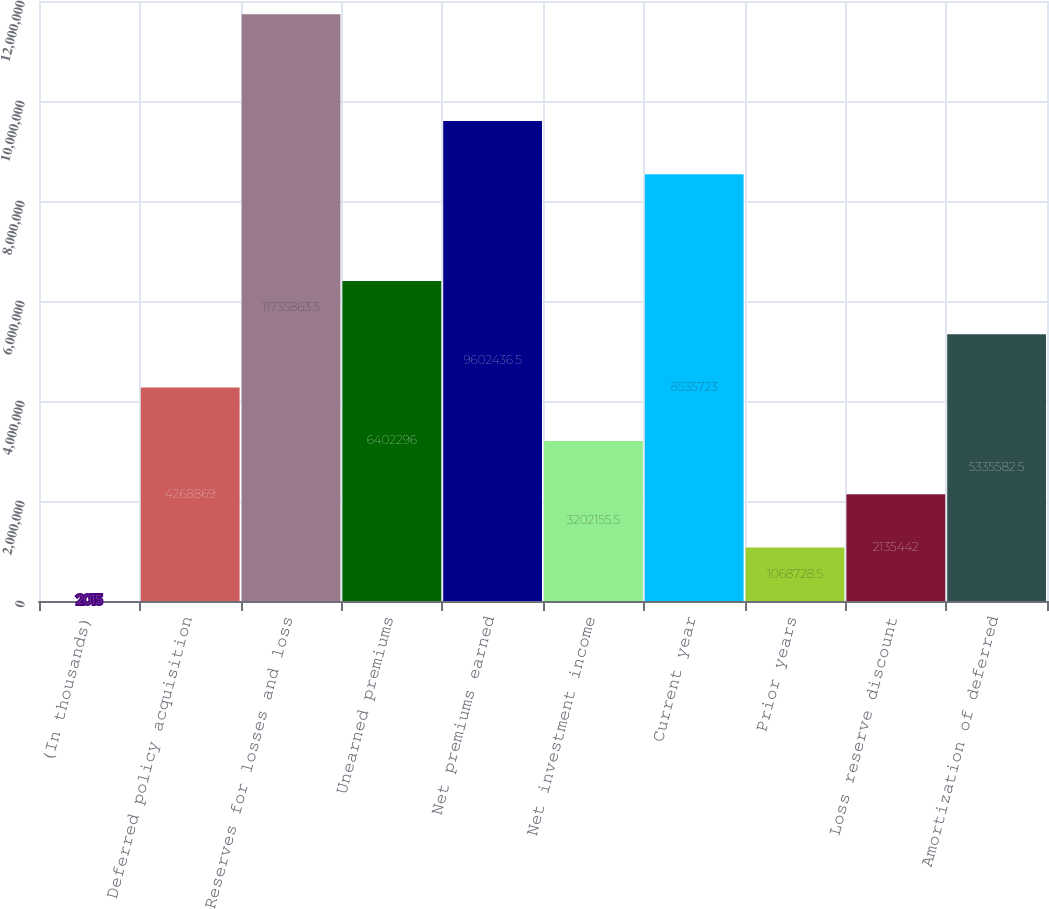Convert chart to OTSL. <chart><loc_0><loc_0><loc_500><loc_500><bar_chart><fcel>(In thousands)<fcel>Deferred policy acquisition<fcel>Reserves for losses and loss<fcel>Unearned premiums<fcel>Net premiums earned<fcel>Net investment income<fcel>Current year<fcel>Prior years<fcel>Loss reserve discount<fcel>Amortization of deferred<nl><fcel>2015<fcel>4.26887e+06<fcel>1.17359e+07<fcel>6.4023e+06<fcel>9.60244e+06<fcel>3.20216e+06<fcel>8.53572e+06<fcel>1.06873e+06<fcel>2.13544e+06<fcel>5.33558e+06<nl></chart> 